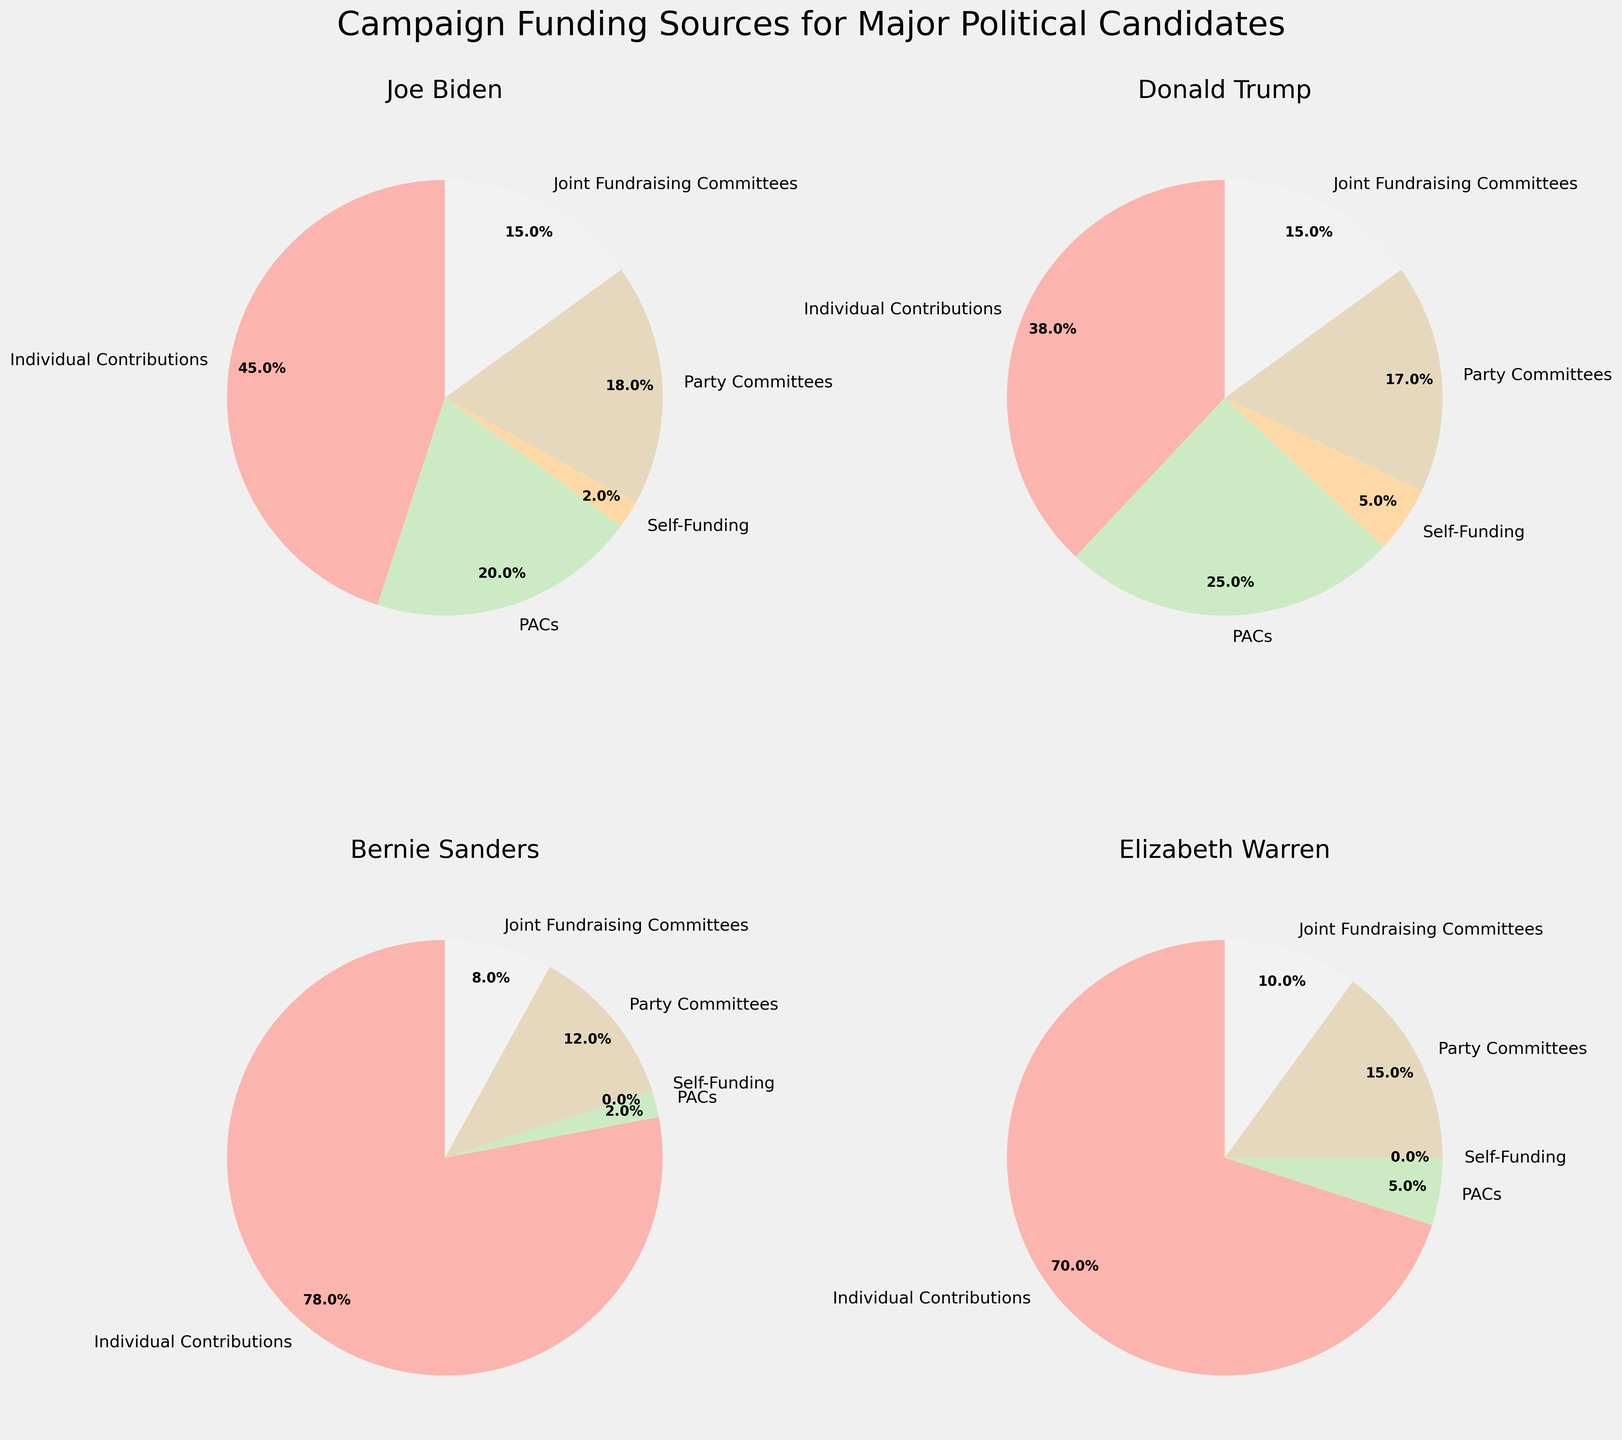Which candidate has the highest percentage of individual contributions? Examine the individual pie segments labeled "Individual Contributions" and compare the percentages for each candidate. Bernie Sanders has the highest at 78%.
Answer: Bernie Sanders Which candidate relies the most on PACs for their funding? Look at the pie segments labeled "PACs" and compare the percentages. Donald Trump has the highest percentage at 25%.
Answer: Donald Trump What is the total percentage of self-funding for Joe Biden and Donald Trump combined? Add Joe Biden's self-funding percentage (2%) to Donald Trump's self-funding percentage (5%).
Answer: 7% How does the percentage of party committee funding for Elizabeth Warren compare to that of Bernie Sanders? Find the pie segments labeled "Party Committees" and compare them. Both candidates have 15% and 12% respectively, thus Elizabeth Warren has a higher percentage.
Answer: Elizabeth Warren Which candidate has the smallest percentage from self-funding? Look at the pie segments labeled "Self-Funding" and compare them. Joe Biden and Elizabeth Warren both have 0%.
Answer: Joe Biden and Elizabeth Warren Is the percentage of individual contributions for Donald Trump greater than for Joe Biden? Compare the pie segments of "Individual Contributions" for Joe Biden (45%) and Donald Trump (38%). Joe Biden's percentage is greater.
Answer: No Which funding source contributes the least to Bernie Sanders' campaign? Identify the smallest pie segment in Bernie Sanders' chart. The "Self-Funding" segment is 0%.
Answer: Self-Funding Are Joint Fundraising Committees' contributions equal for Joe Biden and Donald Trump? Compare the percentages of the "Joint Fundraising Committees" pie segments for Joe Biden and Donald Trump. Both are 15%.
Answer: Yes How much greater is Elizabeth Warren's percentage of individual contributions compared to her percentage from PACs? Subtract the percentage of PACs (5%) from the percentage of individual contributions (70%).
Answer: 65% What is the combined percentage of Party Committee funding for all candidates? Add the percentages of Party Committees for each candidate (Joe Biden: 18%, Donald Trump: 17%, Bernie Sanders: 12%, Elizabeth Warren: 15%).
Answer: 62% 